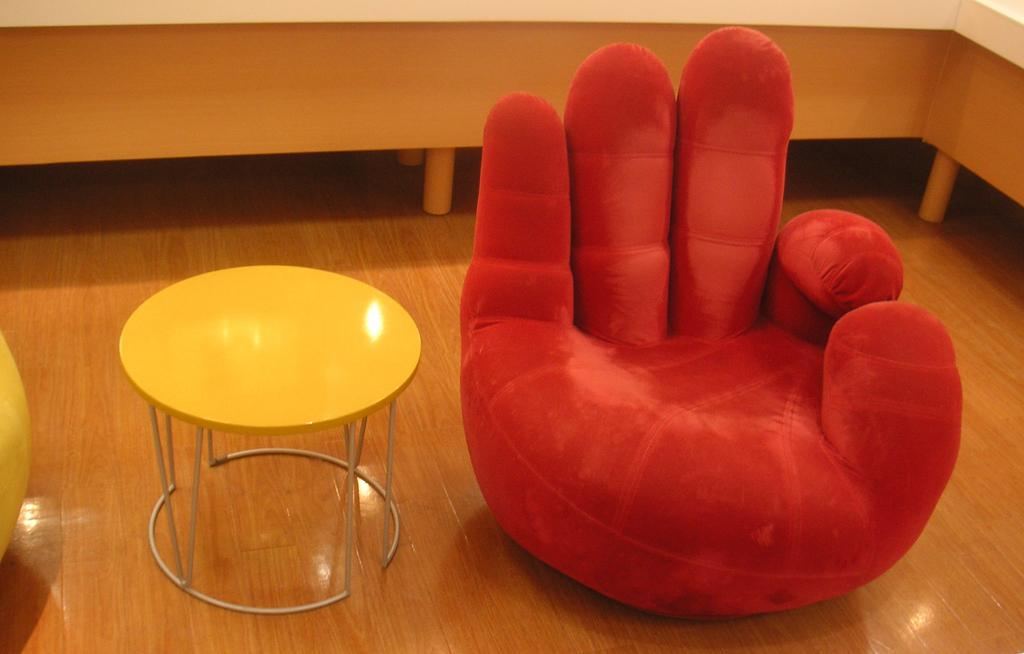What type of furniture is on the floor in the image? There is a table and a chair on the floor in the image. What is the color of the chair? The chair is designed in red color. Is there a twig being used as a spoon in the image? There is no twig or spoon present in the image. 